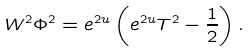<formula> <loc_0><loc_0><loc_500><loc_500>W ^ { 2 } \Phi ^ { 2 } = e ^ { 2 u } \left ( e ^ { 2 u } T ^ { 2 } - \frac { 1 } { 2 } \right ) .</formula> 